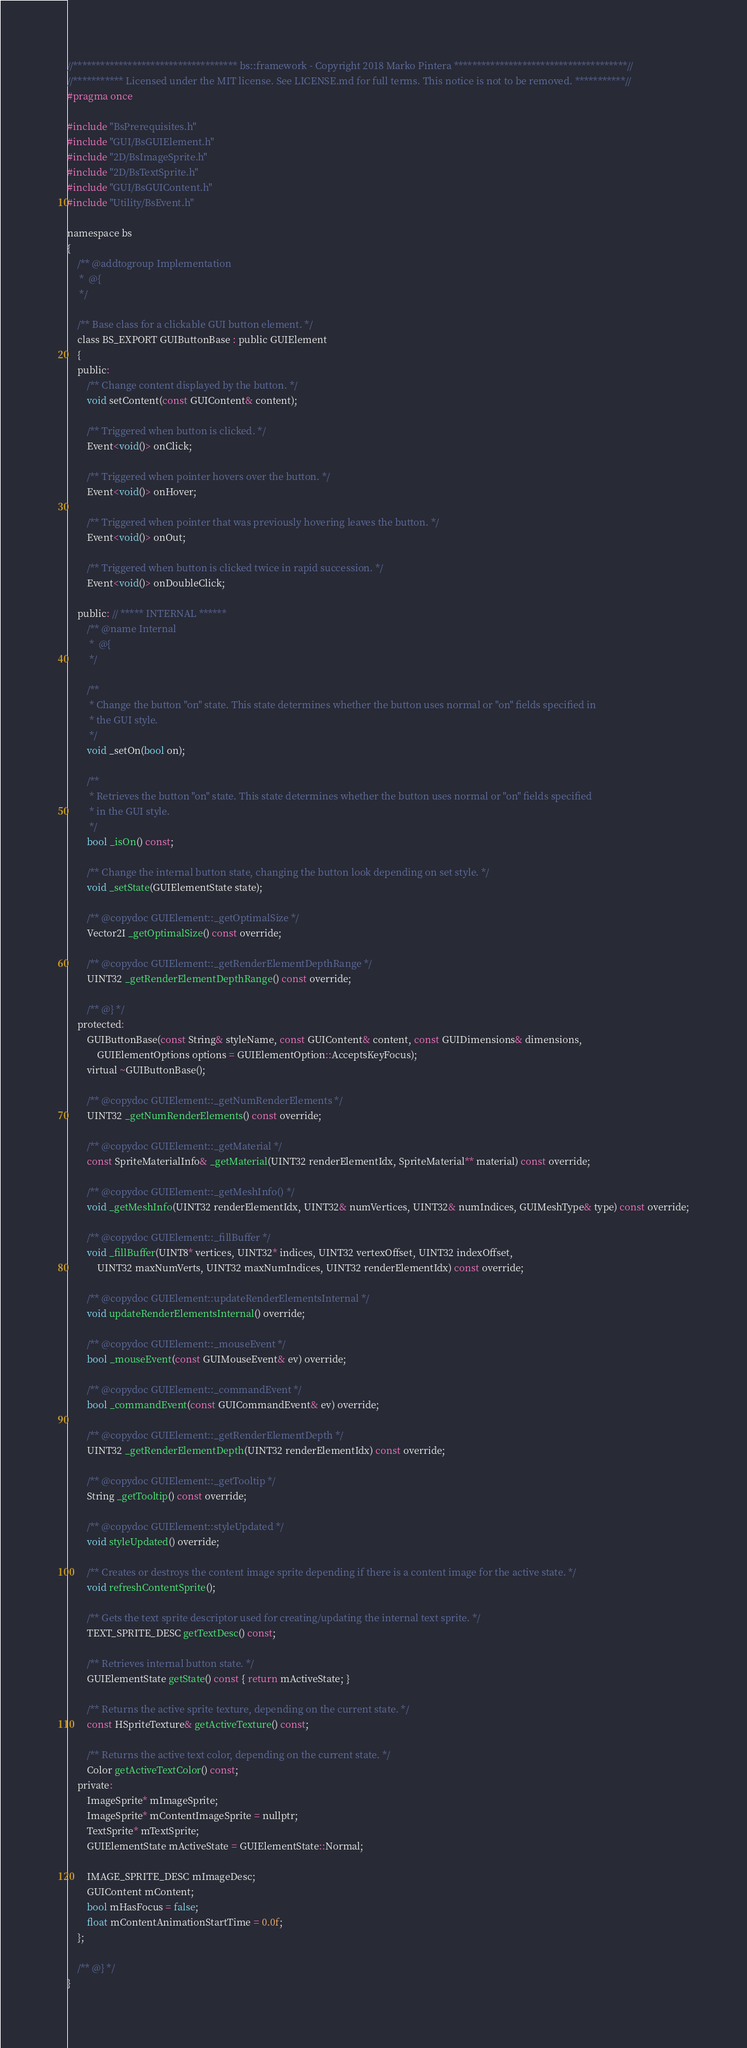<code> <loc_0><loc_0><loc_500><loc_500><_C_>//************************************ bs::framework - Copyright 2018 Marko Pintera **************************************//
//*********** Licensed under the MIT license. See LICENSE.md for full terms. This notice is not to be removed. ***********//
#pragma once

#include "BsPrerequisites.h"
#include "GUI/BsGUIElement.h"
#include "2D/BsImageSprite.h"
#include "2D/BsTextSprite.h"
#include "GUI/BsGUIContent.h"
#include "Utility/BsEvent.h"

namespace bs
{
	/** @addtogroup Implementation
	 *  @{
	 */

	/**	Base class for a clickable GUI button element. */	
	class BS_EXPORT GUIButtonBase : public GUIElement
	{
	public:
		/**	Change content displayed by the button. */
		void setContent(const GUIContent& content);

		/**	Triggered when button is clicked. */
		Event<void()> onClick;

		/**	Triggered when pointer hovers over the button. */
		Event<void()> onHover;

		/**	Triggered when pointer that was previously hovering leaves the button. */
		Event<void()> onOut;

		/**	Triggered when button is clicked twice in rapid succession. */
		Event<void()> onDoubleClick;

	public: // ***** INTERNAL ******
		/** @name Internal
		 *  @{
		 */

		/**
		 * Change the button "on" state. This state determines whether the button uses normal or "on" fields specified in
		 * the GUI style.
		 */
		void _setOn(bool on);

		/**
		 * Retrieves the button "on" state. This state determines whether the button uses normal or "on" fields specified
		 * in the GUI style.
		 */
		bool _isOn() const;

		/**	Change the internal button state, changing the button look depending on set style. */
		void _setState(GUIElementState state);

		/** @copydoc GUIElement::_getOptimalSize */
		Vector2I _getOptimalSize() const override;

		/** @copydoc GUIElement::_getRenderElementDepthRange */
		UINT32 _getRenderElementDepthRange() const override;

		/** @} */
	protected:
		GUIButtonBase(const String& styleName, const GUIContent& content, const GUIDimensions& dimensions,
			GUIElementOptions options = GUIElementOption::AcceptsKeyFocus);
		virtual ~GUIButtonBase();

		/** @copydoc GUIElement::_getNumRenderElements */
		UINT32 _getNumRenderElements() const override;

		/** @copydoc GUIElement::_getMaterial */
		const SpriteMaterialInfo& _getMaterial(UINT32 renderElementIdx, SpriteMaterial** material) const override;

		/** @copydoc GUIElement::_getMeshInfo() */
		void _getMeshInfo(UINT32 renderElementIdx, UINT32& numVertices, UINT32& numIndices, GUIMeshType& type) const override;

		/** @copydoc GUIElement::_fillBuffer */
		void _fillBuffer(UINT8* vertices, UINT32* indices, UINT32 vertexOffset, UINT32 indexOffset,
			UINT32 maxNumVerts, UINT32 maxNumIndices, UINT32 renderElementIdx) const override;

		/** @copydoc GUIElement::updateRenderElementsInternal */
		void updateRenderElementsInternal() override;

		/** @copydoc GUIElement::_mouseEvent */
		bool _mouseEvent(const GUIMouseEvent& ev) override;

		/** @copydoc GUIElement::_commandEvent */
		bool _commandEvent(const GUICommandEvent& ev) override;

		/** @copydoc GUIElement::_getRenderElementDepth */
		UINT32 _getRenderElementDepth(UINT32 renderElementIdx) const override;

		/** @copydoc GUIElement::_getTooltip */
		String _getTooltip() const override;

		/** @copydoc GUIElement::styleUpdated */
		void styleUpdated() override;

		/** Creates or destroys the content image sprite depending if there is a content image for the active state. */
		void refreshContentSprite();

		/**	Gets the text sprite descriptor used for creating/updating the internal text sprite. */
		TEXT_SPRITE_DESC getTextDesc() const;

		/**	Retrieves internal button state. */
		GUIElementState getState() const { return mActiveState; }

		/**	Returns the active sprite texture, depending on the current state. */
		const HSpriteTexture& getActiveTexture() const;

		/**	Returns the active text color, depending on the current state. */
		Color getActiveTextColor() const;
	private:
		ImageSprite* mImageSprite;
		ImageSprite* mContentImageSprite = nullptr;
		TextSprite* mTextSprite;
		GUIElementState mActiveState = GUIElementState::Normal;

		IMAGE_SPRITE_DESC mImageDesc;
		GUIContent mContent;
		bool mHasFocus = false;
		float mContentAnimationStartTime = 0.0f;
	};

	/** @} */
}
</code> 